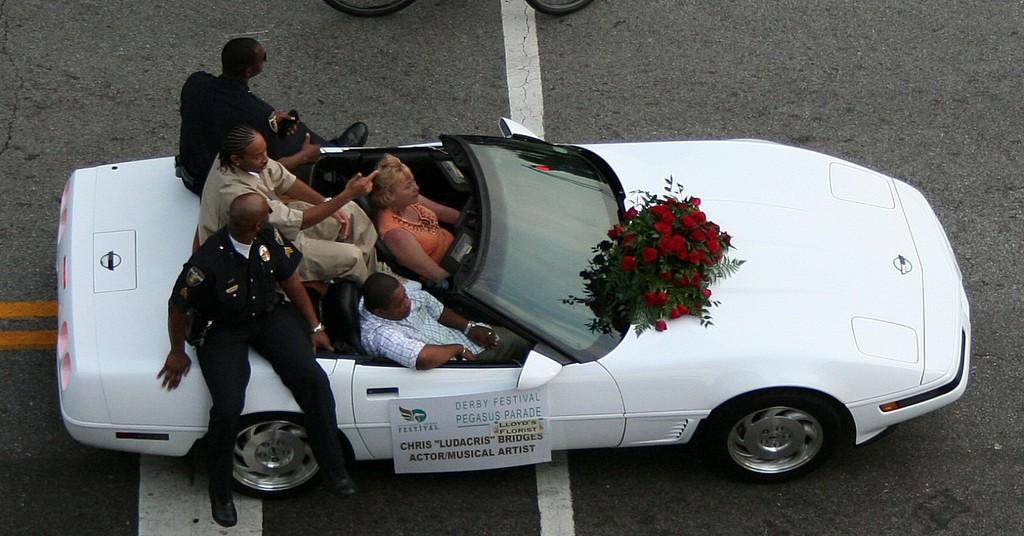Could you give a brief overview of what you see in this image? In this image there are group of people sitting in the car , there is a name board or paper stick to the car , a flower bouquet in middle of the car, there is a person driving the car in the street. 